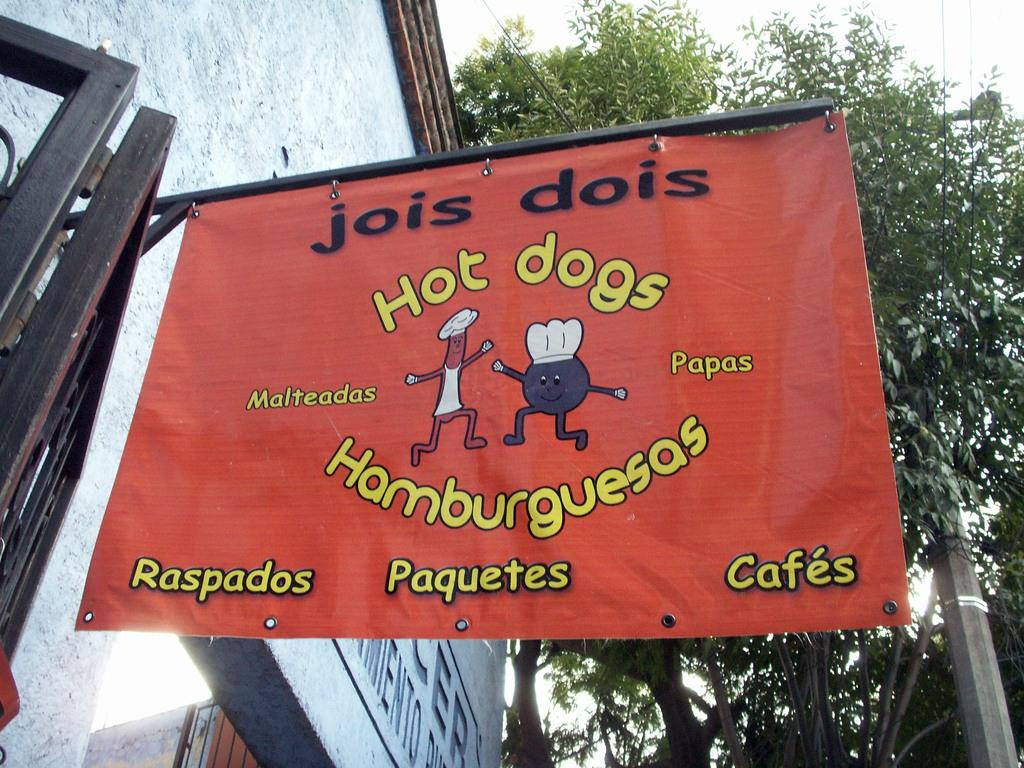What type of structure is present in the image? There is a building in the image. What can be seen on the wall of the building? There is text on the wall of the building. What else in the image has text on it? There is a banner with text in the image. What type of natural elements can be seen in the image? There are trees visible in the image. How would you describe the weather in the image? The sky is cloudy in the image. How many slaves are depicted in the image? There are no slaves present in the image. What is the interest rate mentioned on the banner in the image? There is no mention of an interest rate on the banner in the image. 